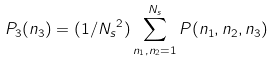<formula> <loc_0><loc_0><loc_500><loc_500>P _ { 3 } ( n _ { 3 } ) = ( 1 / { N _ { s } } ^ { 2 } ) \sum _ { n _ { 1 } , n _ { 2 } = 1 } ^ { N _ { s } } P ( n _ { 1 } , n _ { 2 } , n _ { 3 } ) \,</formula> 